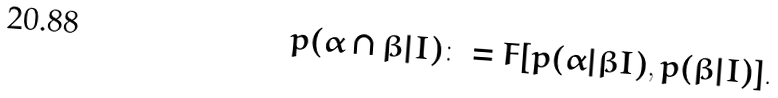<formula> <loc_0><loc_0><loc_500><loc_500>p ( \alpha \cap \beta | I ) \colon = F [ p ( \alpha | \beta I ) , p ( \beta | I ) ] .</formula> 